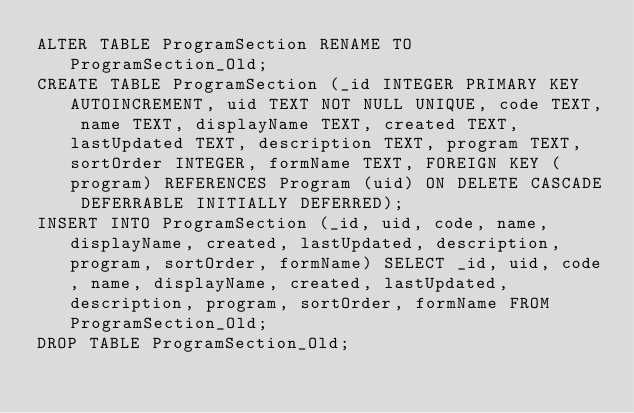Convert code to text. <code><loc_0><loc_0><loc_500><loc_500><_SQL_>ALTER TABLE ProgramSection RENAME TO ProgramSection_Old;
CREATE TABLE ProgramSection (_id INTEGER PRIMARY KEY AUTOINCREMENT, uid TEXT NOT NULL UNIQUE, code TEXT, name TEXT, displayName TEXT, created TEXT, lastUpdated TEXT, description TEXT, program TEXT, sortOrder INTEGER, formName TEXT, FOREIGN KEY (program) REFERENCES Program (uid) ON DELETE CASCADE DEFERRABLE INITIALLY DEFERRED);
INSERT INTO ProgramSection (_id, uid, code, name, displayName, created, lastUpdated, description, program, sortOrder, formName) SELECT _id, uid, code, name, displayName, created, lastUpdated, description, program, sortOrder, formName FROM ProgramSection_Old;
DROP TABLE ProgramSection_Old;</code> 